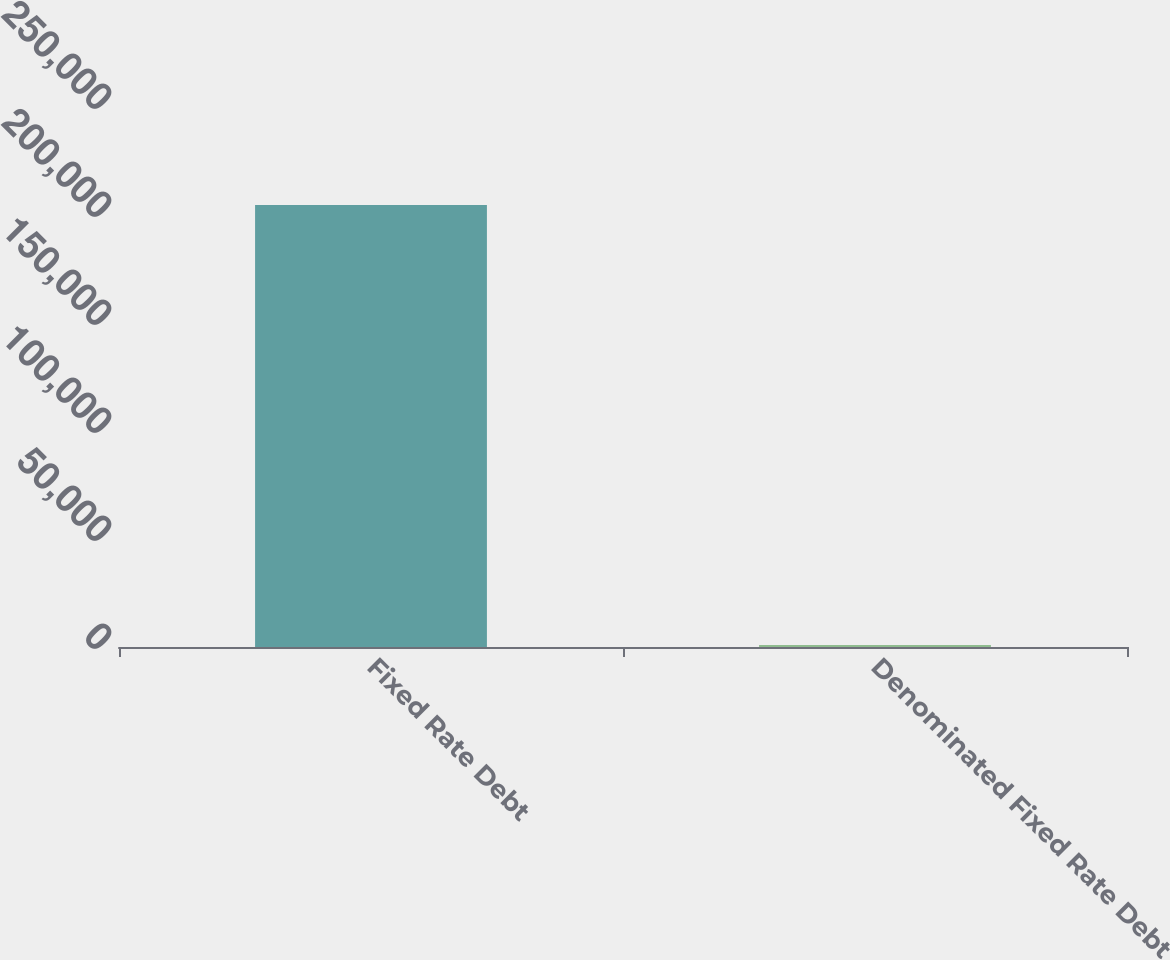Convert chart. <chart><loc_0><loc_0><loc_500><loc_500><bar_chart><fcel>Fixed Rate Debt<fcel>Denominated Fixed Rate Debt<nl><fcel>204658<fcel>957<nl></chart> 